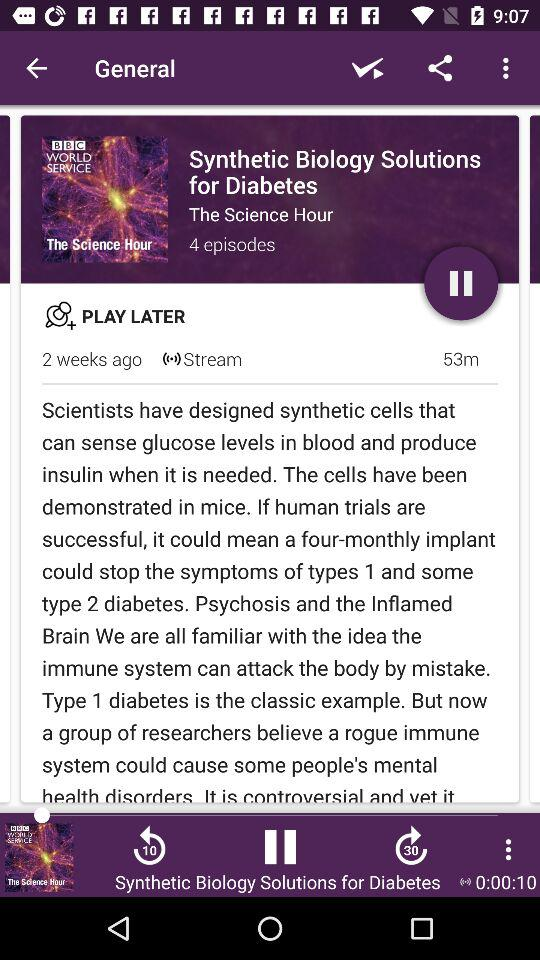What is the series name? The name of the series is "The Science Hour". 